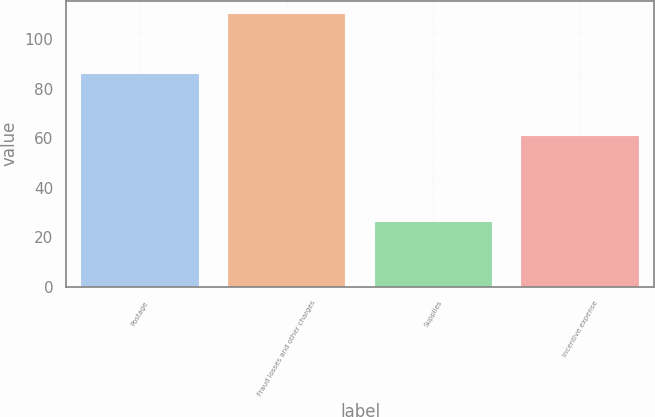<chart> <loc_0><loc_0><loc_500><loc_500><bar_chart><fcel>Postage<fcel>Fraud losses and other charges<fcel>Supplies<fcel>Incentive expense<nl><fcel>86<fcel>110<fcel>26<fcel>61<nl></chart> 